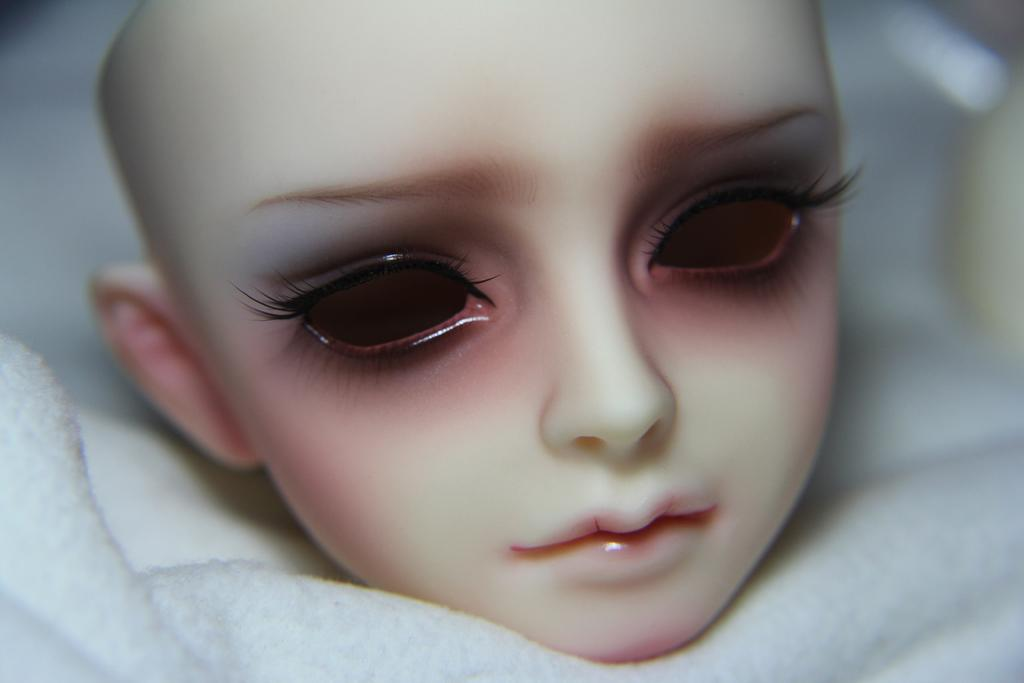What is the main subject of the image? There is a doll in the image. How is the doll positioned in the image? The doll is placed on a white cloth. Can you describe the background of the image? The backdrop of the image is blurred. What is the income of the boys learning in the background of the image? There are no boys or learning activities present in the image; it features a doll placed on a white cloth with a blurred background. 